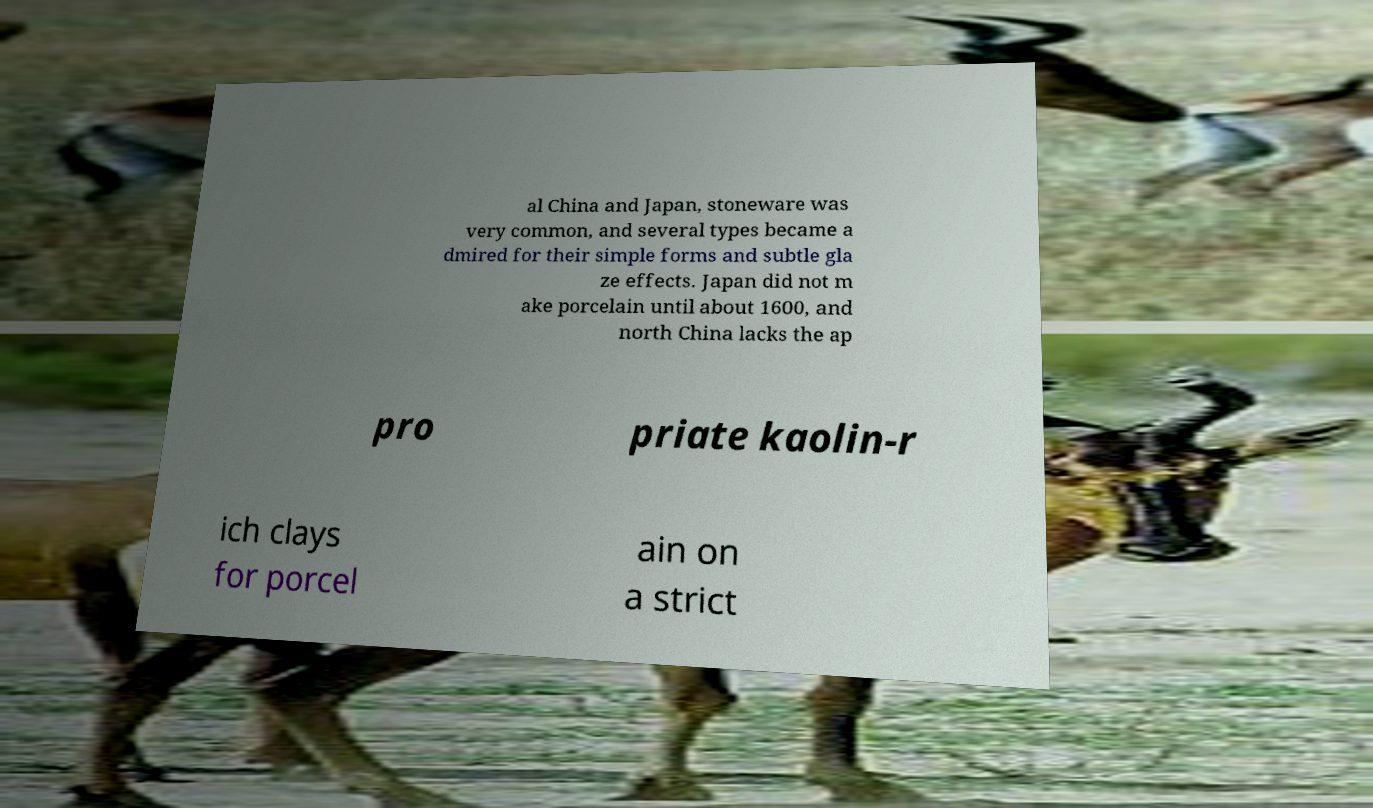Can you read and provide the text displayed in the image?This photo seems to have some interesting text. Can you extract and type it out for me? al China and Japan, stoneware was very common, and several types became a dmired for their simple forms and subtle gla ze effects. Japan did not m ake porcelain until about 1600, and north China lacks the ap pro priate kaolin-r ich clays for porcel ain on a strict 